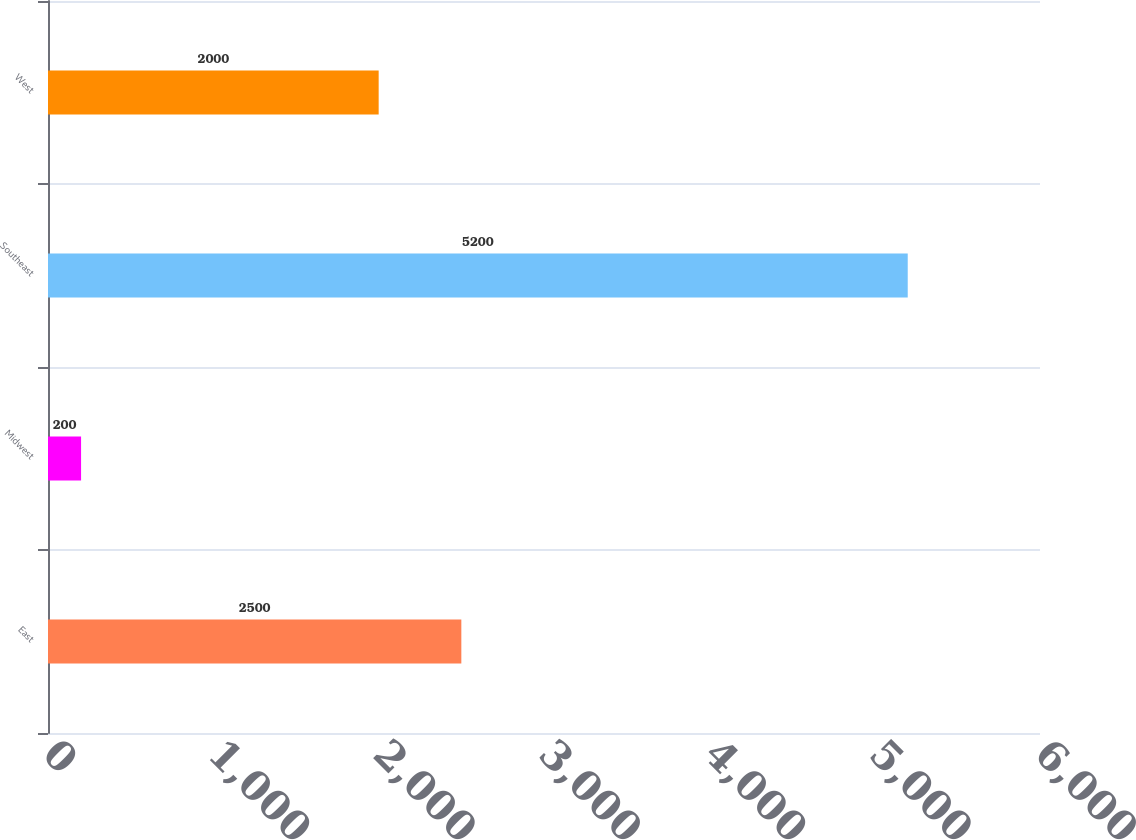Convert chart. <chart><loc_0><loc_0><loc_500><loc_500><bar_chart><fcel>East<fcel>Midwest<fcel>Southeast<fcel>West<nl><fcel>2500<fcel>200<fcel>5200<fcel>2000<nl></chart> 